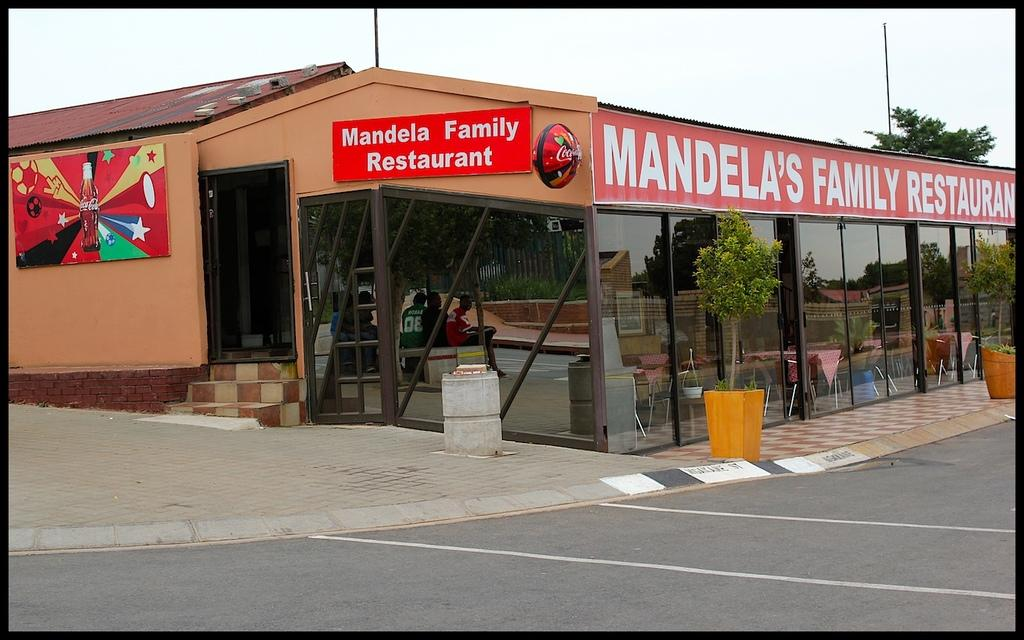What type of establishment is in the foreground of the image? There is a restaurant in the foreground of the image. What decorative elements can be seen in the foreground of the image? There are houseplants in the foreground of the image. What furniture is present in the foreground of the image? There are tables and chairs in the foreground of the image. What activity is taking place in the foreground of the image? There is a group of people sitting in the foreground of the image. What can be seen in the sky at the top of the image? The sky is visible at the top of the image, and it was taken during the day. What type of vegetation is visible at the top of the image? Trees are visible at the top of the image. How many guns are visible in the image? There are no guns visible in the image. 